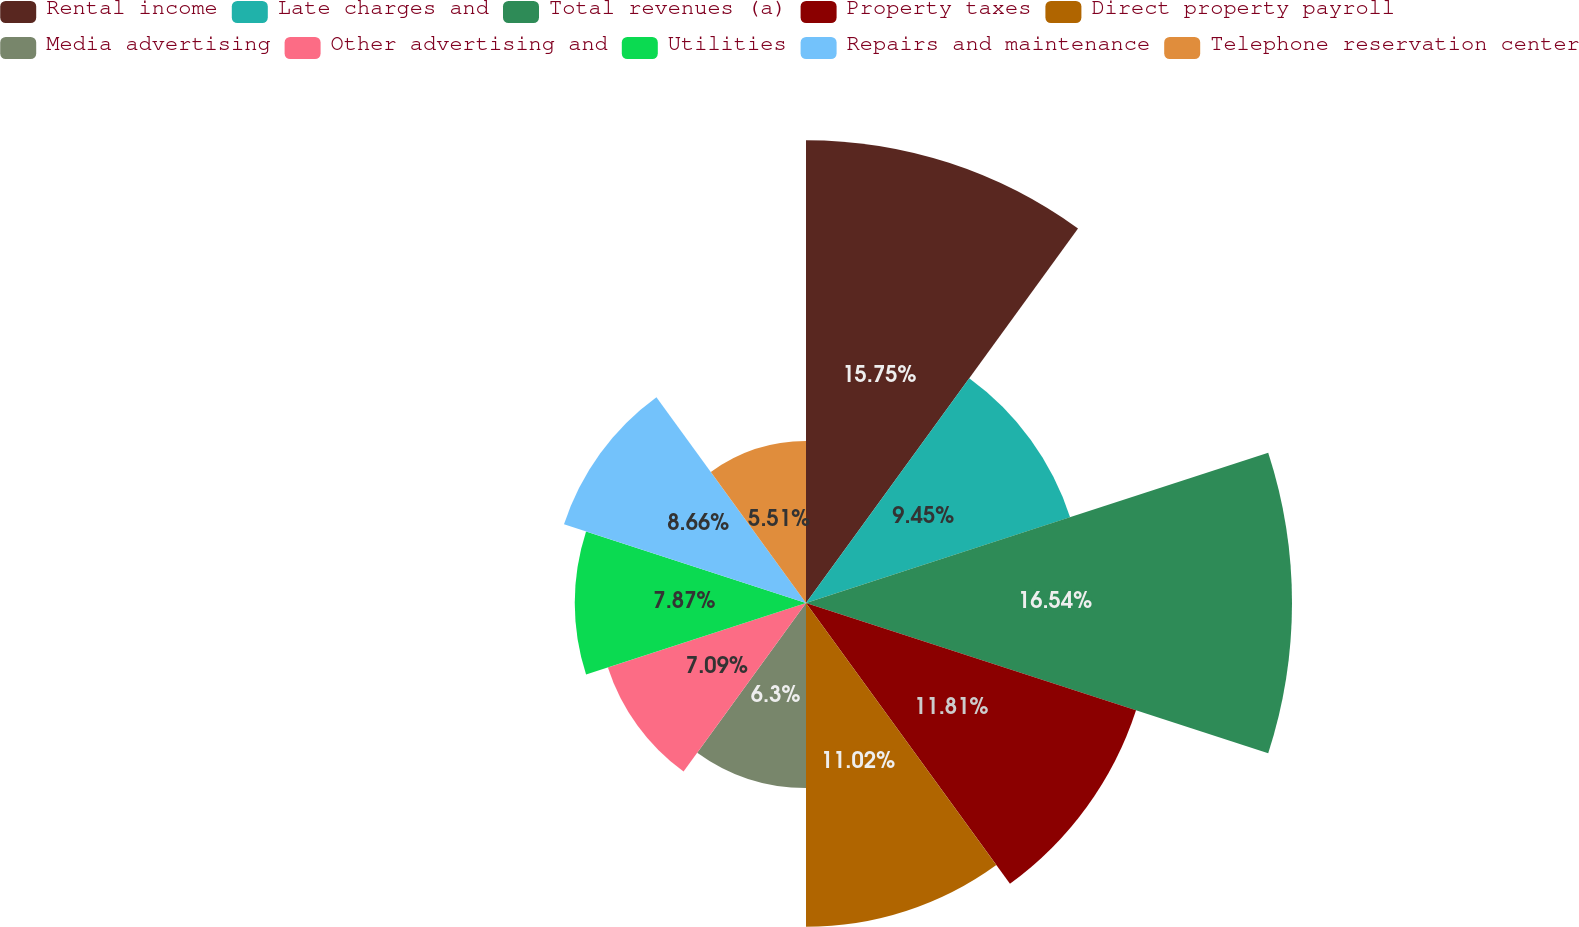Convert chart. <chart><loc_0><loc_0><loc_500><loc_500><pie_chart><fcel>Rental income<fcel>Late charges and<fcel>Total revenues (a)<fcel>Property taxes<fcel>Direct property payroll<fcel>Media advertising<fcel>Other advertising and<fcel>Utilities<fcel>Repairs and maintenance<fcel>Telephone reservation center<nl><fcel>15.75%<fcel>9.45%<fcel>16.54%<fcel>11.81%<fcel>11.02%<fcel>6.3%<fcel>7.09%<fcel>7.87%<fcel>8.66%<fcel>5.51%<nl></chart> 